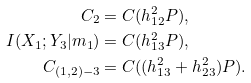Convert formula to latex. <formula><loc_0><loc_0><loc_500><loc_500>C _ { 2 } & = C ( h _ { 1 2 } ^ { 2 } P ) , \\ I ( X _ { 1 } ; Y _ { 3 } | m _ { 1 } ) & = C ( h _ { 1 3 } ^ { 2 } P ) , \\ C _ { ( 1 , 2 ) - 3 } & = C ( ( h _ { 1 3 } ^ { 2 } + h _ { 2 3 } ^ { 2 } ) P ) .</formula> 